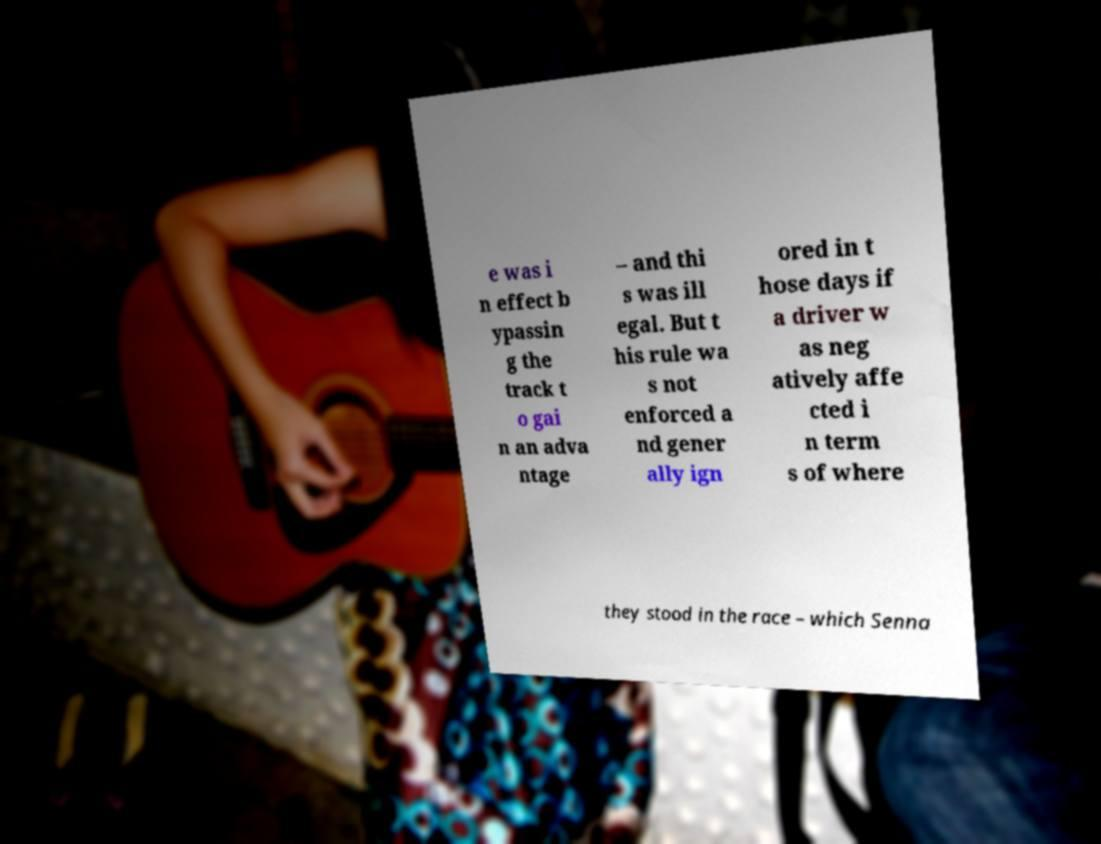There's text embedded in this image that I need extracted. Can you transcribe it verbatim? e was i n effect b ypassin g the track t o gai n an adva ntage – and thi s was ill egal. But t his rule wa s not enforced a nd gener ally ign ored in t hose days if a driver w as neg atively affe cted i n term s of where they stood in the race – which Senna 